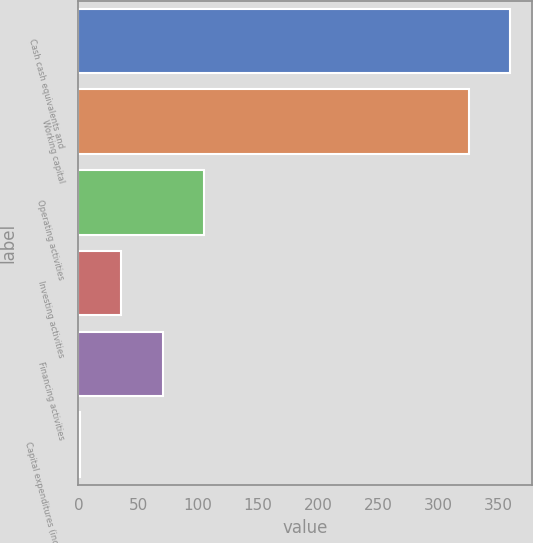<chart> <loc_0><loc_0><loc_500><loc_500><bar_chart><fcel>Cash cash equivalents and<fcel>Working capital<fcel>Operating activities<fcel>Investing activities<fcel>Financing activities<fcel>Capital expenditures (included<nl><fcel>360.44<fcel>326.1<fcel>104.62<fcel>35.94<fcel>70.28<fcel>1.6<nl></chart> 